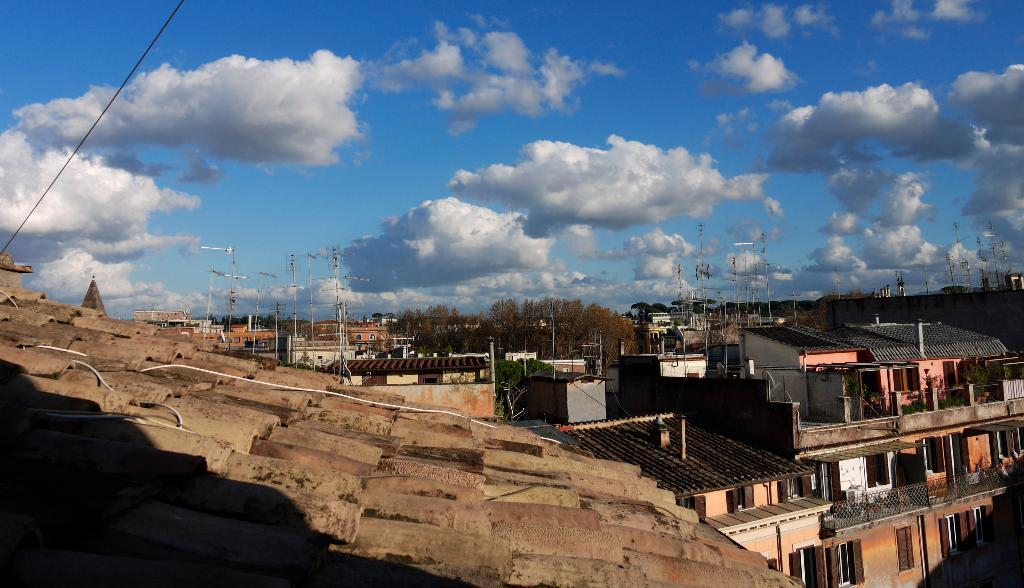What types of structures are located at the bottom of the image? There are buildings at the bottom of the image. What other objects can be seen at the bottom of the image? There are trees, poles, and plants at the bottom of the image. What is visible at the top of the image? There are clouds and sky visible at the top of the image. Can you tell me how many shoes are hanging from the trees in the image? There are no shoes present in the image; it features buildings, trees, poles, plants, clouds, and sky. What message of peace can be seen in the image? There is no message of peace depicted in the image. 